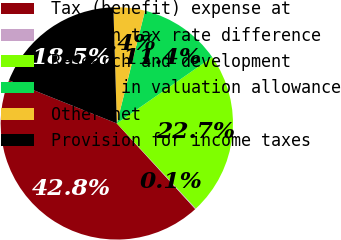<chart> <loc_0><loc_0><loc_500><loc_500><pie_chart><fcel>Tax (benefit) expense at<fcel>Foreign tax rate difference<fcel>Research and development<fcel>Change in valuation allowance<fcel>Other net<fcel>Provision for income taxes<nl><fcel>42.85%<fcel>0.11%<fcel>22.75%<fcel>11.44%<fcel>4.38%<fcel>18.48%<nl></chart> 